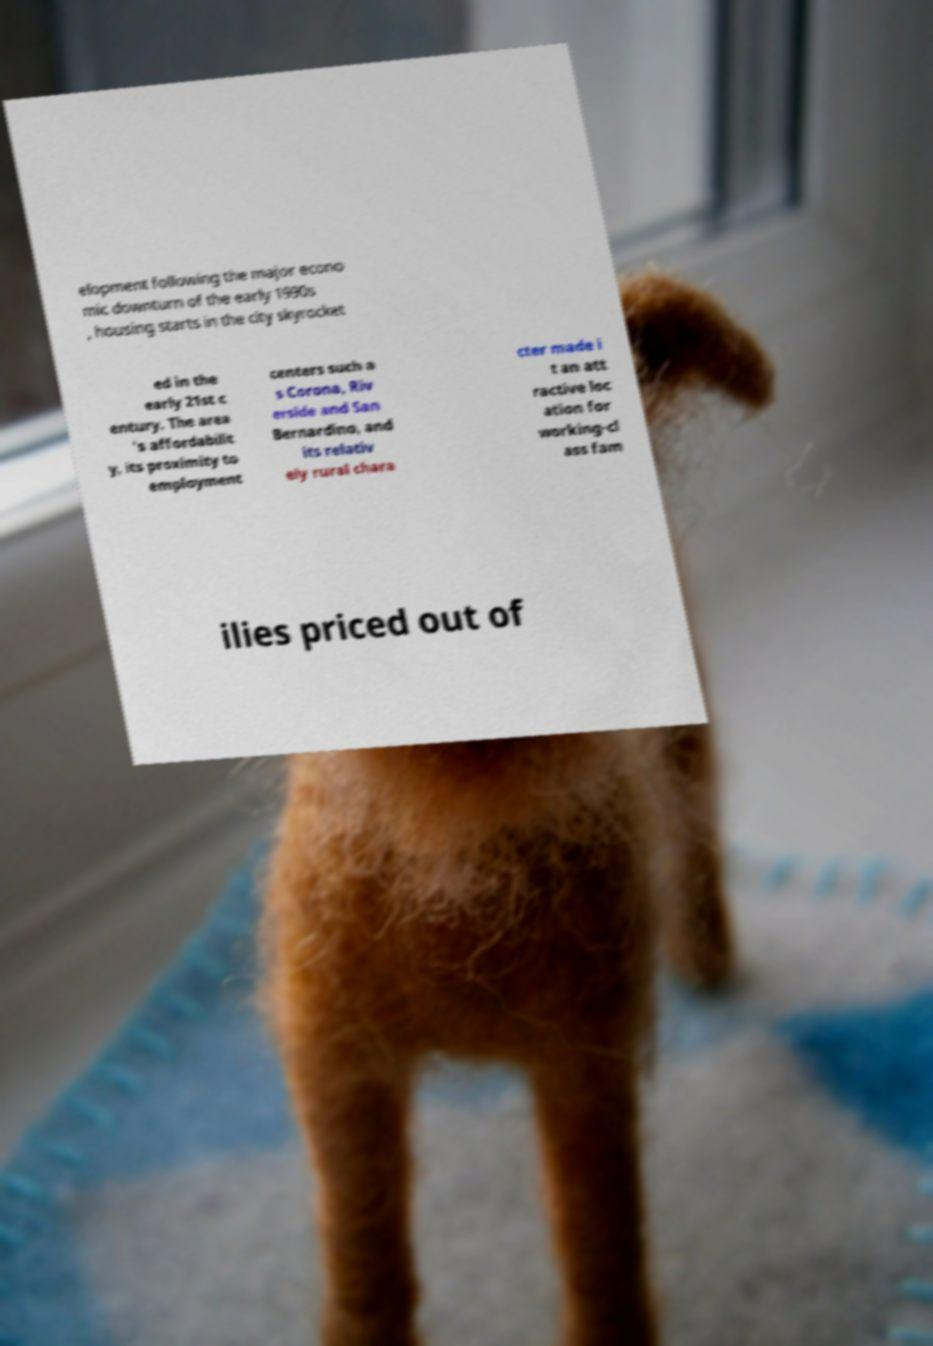Could you assist in decoding the text presented in this image and type it out clearly? elopment following the major econo mic downturn of the early 1990s , housing starts in the city skyrocket ed in the early 21st c entury. The area 's affordabilit y, its proximity to employment centers such a s Corona, Riv erside and San Bernardino, and its relativ ely rural chara cter made i t an att ractive loc ation for working-cl ass fam ilies priced out of 